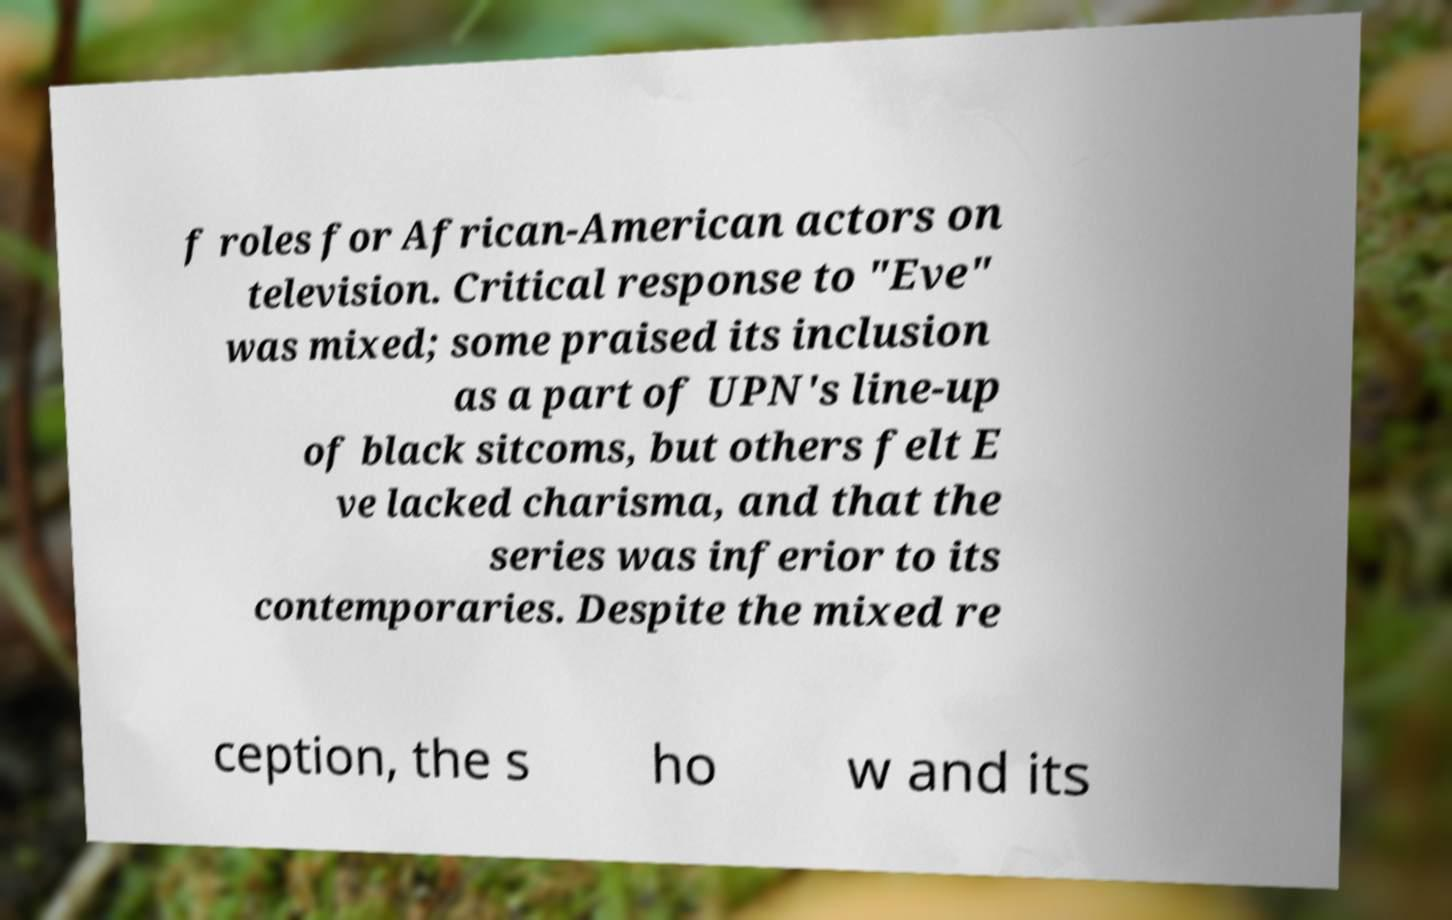I need the written content from this picture converted into text. Can you do that? f roles for African-American actors on television. Critical response to "Eve" was mixed; some praised its inclusion as a part of UPN's line-up of black sitcoms, but others felt E ve lacked charisma, and that the series was inferior to its contemporaries. Despite the mixed re ception, the s ho w and its 